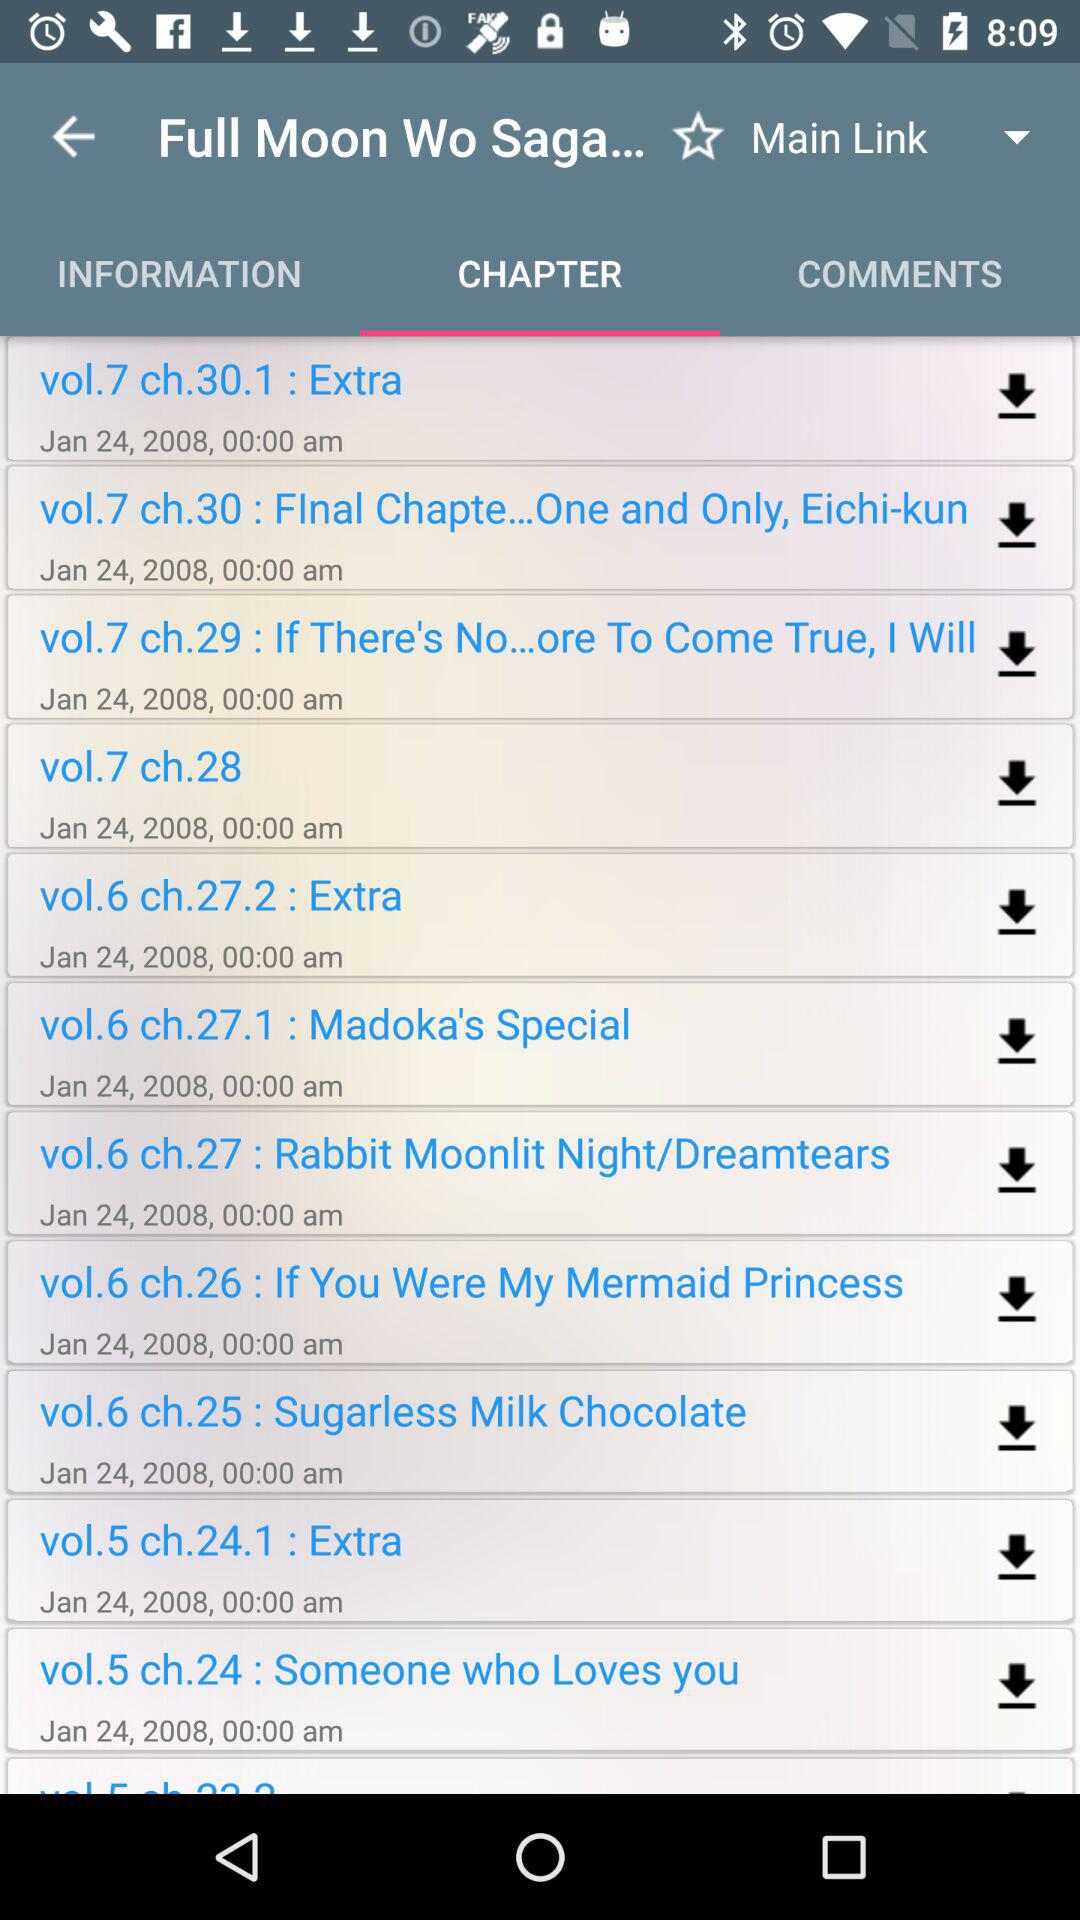How many more chapters are there in volume 6 than in volume 7?
Answer the question using a single word or phrase. 1 